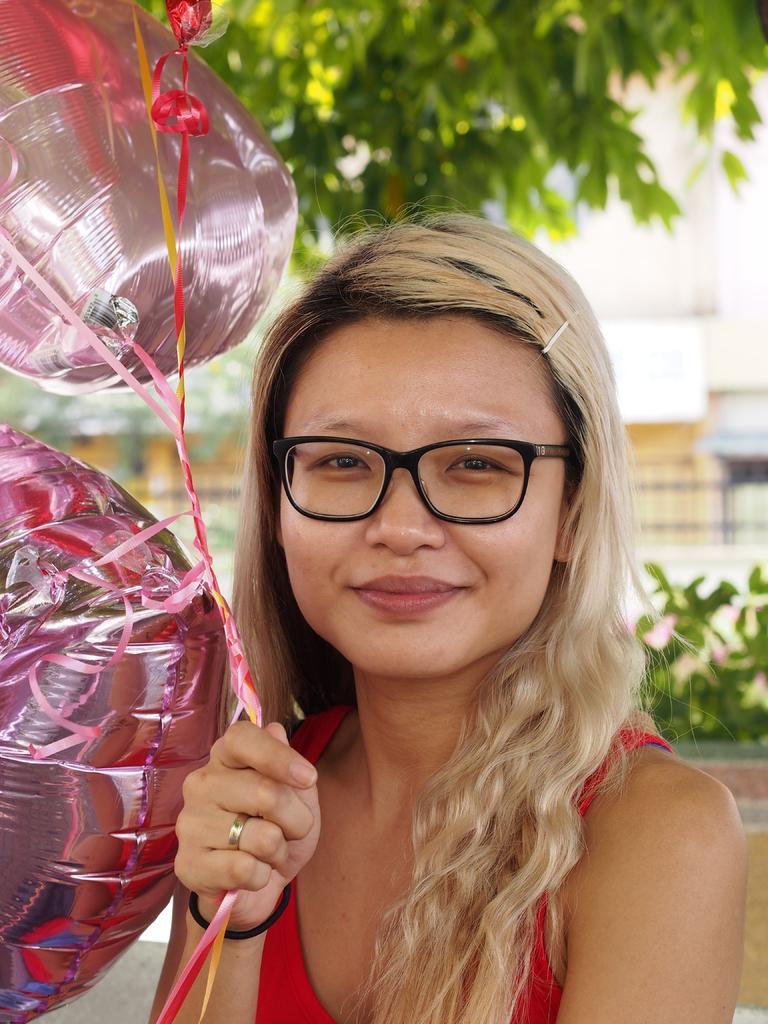In one or two sentences, can you explain what this image depicts? In the middle of the image a girl is standing and smiling and holding some balloons. Behind her there are some plants and trees and buildings. 